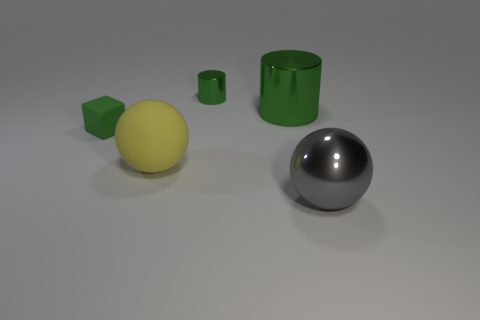How many objects are there in this image, and can you describe their shapes? In the image, there are four distinct objects. Starting from the left, there is a small green cube, followed by a larger yellow sphere. Toward the right, there is a green cylindrical object with an open top, and finally, there is a silver or chrome sphere exhibiting a glossy surface that clearly reflects its surroundings. 